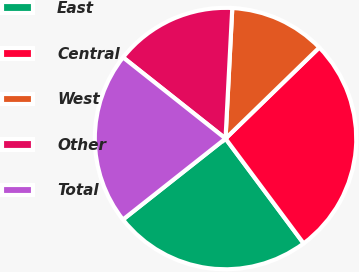Convert chart. <chart><loc_0><loc_0><loc_500><loc_500><pie_chart><fcel>East<fcel>Central<fcel>West<fcel>Other<fcel>Total<nl><fcel>24.55%<fcel>27.08%<fcel>11.91%<fcel>15.16%<fcel>21.3%<nl></chart> 